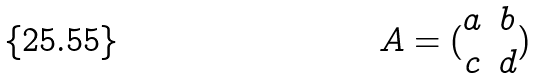<formula> <loc_0><loc_0><loc_500><loc_500>A = ( \begin{matrix} a & b \\ c & d \\ \end{matrix} )</formula> 